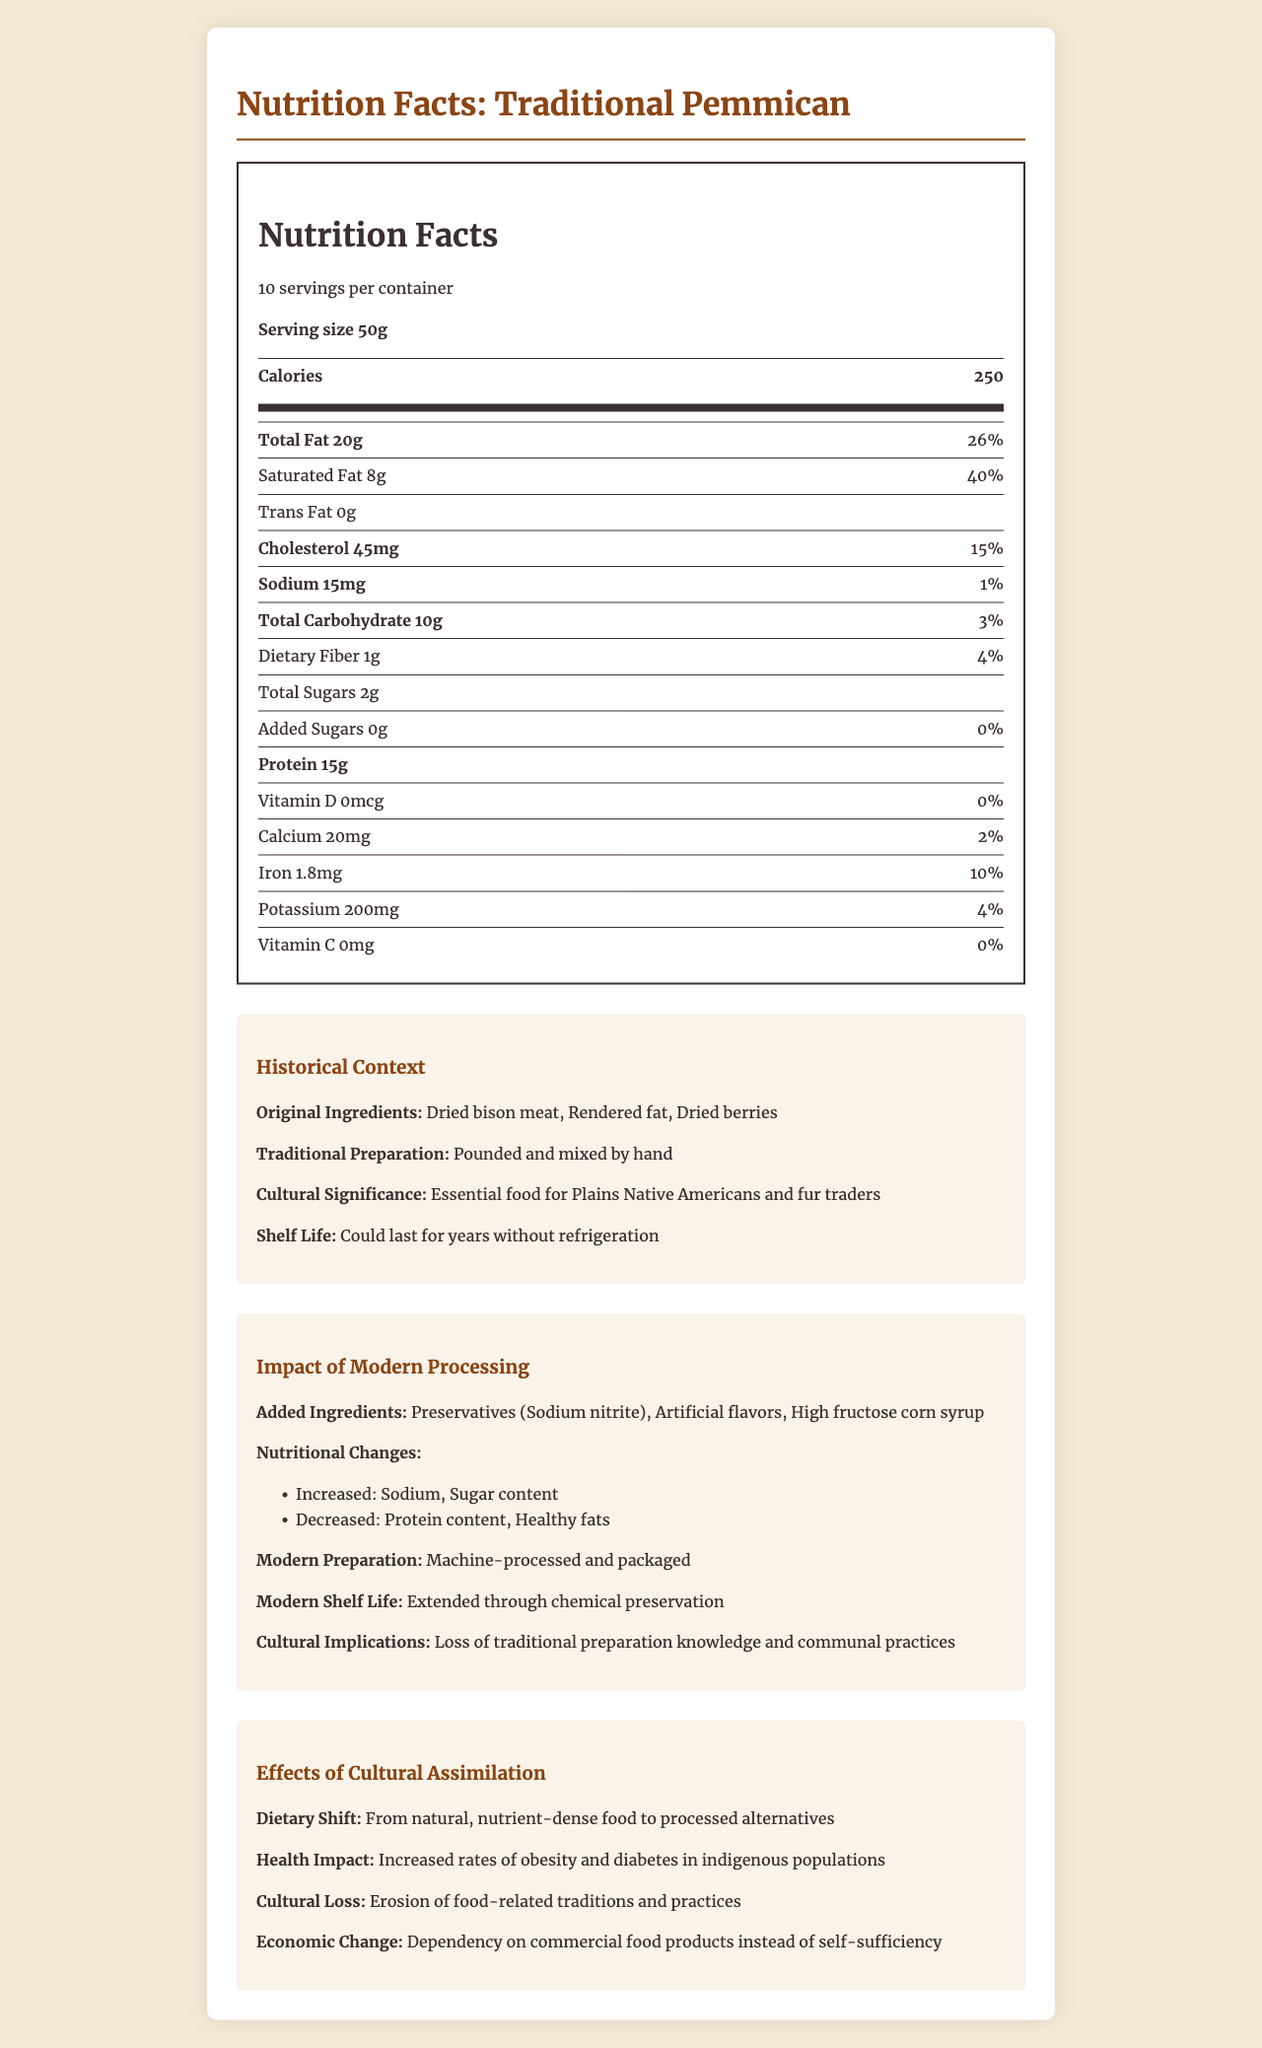what is the serving size? The serving size is explicitly mentioned in the document under the nutrition label section: "Serving size 50g".
Answer: 50g how many servings per container are there? The document states "10 servings per container" in the nutrition label section.
Answer: 10 how many calories are in one serving of Traditional Pemmican? The number of calories per serving is listed as 250 in the nutrition label.
Answer: 250 how much sodium does one serving contain? The amount of sodium per serving is listed as 15mg in the nutrition facts.
Answer: 15mg what are the original ingredients of Traditional Pemmican? The original ingredients are listed under the Historical Context section: "Original Ingredients: Dried bison meat, Rendered fat, Dried berries".
Answer: Dried bison meat, Rendered fat, Dried berries how much dietary fiber is in one serving? A. 1g B. 2g C. 3g The amount of dietary fiber per serving is listed as 1g in the nutrition label.
Answer: A. 1g which of the following nutrients is not increased by modern processing? 1. Sodium 2. Sugar content 3. Protein content The document states under Modern Processing Impact that modern processing has led to an increase in sodium and sugar content, but a decrease in protein content.
Answer: 3. Protein content do Traditional Pemmican contain added sugars? The nutrition label specifies "Added Sugars 0g Daily Value 0%", indicating that there are no added sugars.
Answer: No has modern processing impacted the protein content of Traditional Pemmican? According to the Modern Processing Impact section, the protein content has decreased due to modern processing.
Answer: Yes summarize the main idea of the document. The document provides a comprehensive overview, starting with the nutritional facts, highlighting the historical context, and describing the effects of modern processing and cultural assimilation on the traditional food item, emphasizing changes in ingredients, nutritional content, and cultural practices.
Answer: The document details the nutritional facts of Traditional Pemmican, compares its historical preparation and ingredients with modern processed versions, and discusses the impact of cultural assimilation on indigenous dietary habits. how has the shelf life of Traditional Pemmican changed due to modern processing? The Modern Processing Impact section mentions that the shelf life has been extended through chemical preservation.
Answer: Extended through chemical preservation can the specific amount of artificial flavors added in modern processing be determined from the document? The document lists artificial flavors as an added ingredient in modern processing but does not specify the exact amount.
Answer: Not enough information what is the original cultural significance of Traditional Pemmican? The Historical Context section states that Traditional Pemmican was an essential food for Plains Native Americans and fur traders.
Answer: Essential food for Plains Native Americans and fur traders what are some health impacts of the dietary shift due to cultural assimilation? Under the Effects of Cultural Assimilation section, the document outlines that there has been an increase in rates of obesity and diabetes in indigenous populations.
Answer: Increased rates of obesity and diabetes in indigenous populations which vitamins are not present in Traditional Pemmican? The nutrition label indicates that the amounts for Vitamin D and Vitamin C are both "0" with a daily value of "0%".
Answer: Vitamin D and Vitamin C how did traditional preparation methods of Pemmican contribute to its shelf life? The Historical Context section mentions traditional preparation methods, which allowed Pemmican to last for years without refrigeration, emphasizing its long shelf life.
Answer: Pounded and mixed by hand; could last for years without refrigeration 